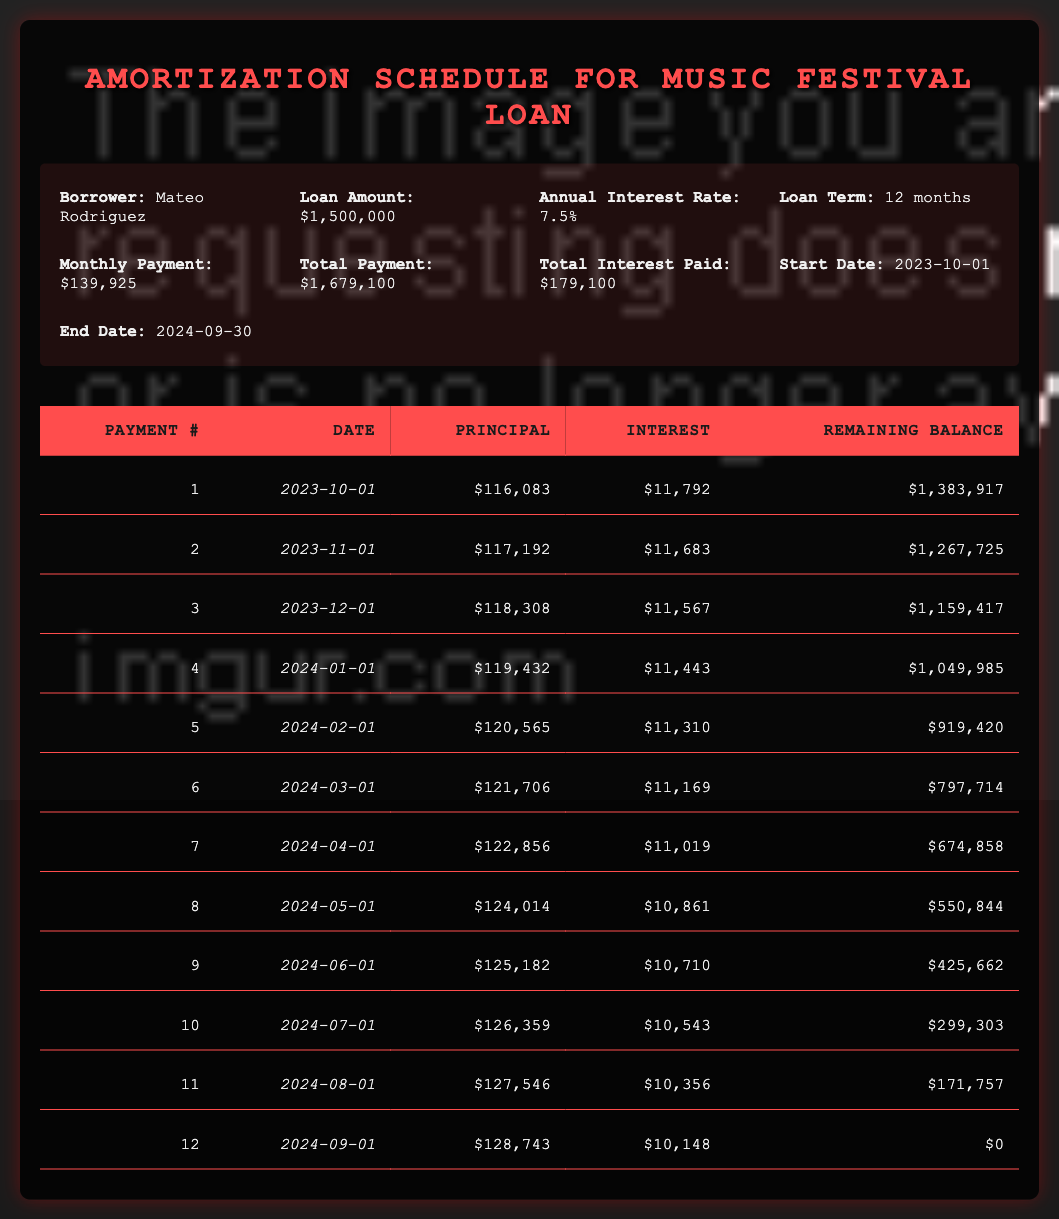What is the monthly payment for Mateo Rodriguez's loan? The monthly payment is listed in the loan details section of the table, which states that the monthly payment is 139925.
Answer: 139925 How much total interest will Mateo pay over the life of the loan? The total interest paid is summarized in the loan details, which shows a total interest of 179100.
Answer: 179100 What is the remaining balance after the 5th payment? To find the remaining balance after the 5th payment, we refer to the amortization schedule and see that for payment number 5, the remaining balance is listed as 919420.
Answer: 919420 What is the average principal payment across all 12 payments? First, we sum the principal payments for all payments: 116083 + 117192 + 118308 + 119432 + 120565 + 121706 + 122856 + 124014 + 125182 + 126359 + 127546 + 128743 = 1,528,176. Then, divide this sum by 12 (the number of payments) to get the average: 1528176 / 12 = 127Receipt.
Answer: 127182 True or False: The total payment amount is greater than the loan amount by more than 500000. The total payment amount is 1679100, and the loan amount is 1500000. The difference is 1679100 - 1500000 = 179100, which is much less than 500000.
Answer: False How much principal was paid in the first and last payment combined? The principal payment for the first payment is 116083 and for the last payment is 128743. Adding these together gives 116083 + 128743 = 244826.
Answer: 244826 What is the interest payment in the 6th month of the loan? The interest payment for the 6th month is listed in the amortization schedule under payment number 6 as 11169.
Answer: 11169 What is the total amount paid in the last payment? The last payment combines both principal and interest, which can be found in the amortization schedule for payment number 12: principal payment is 128743 and interest payment is 10148. Adding those gives 128743 + 10148 = 138891.
Answer: 138891 How does the principal payment in the 4th month compare to the principal payment in the 8th month? The principal payment in the 4th month is 119432 and in the 8th month is 124014. To compare, we see that 124014 is greater than 119432 by 124014 - 119432 = 4582, indicating that the 8th month had a higher payment.
Answer: The 8th month has a higher principal payment by 4582 